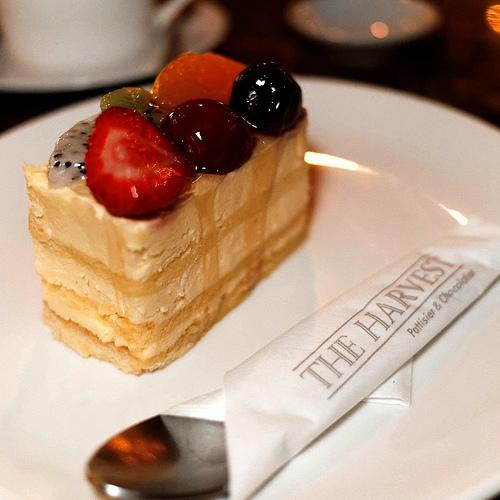Explain how the fruits on top of the cake have been prepared or presented. The fruits have been sliced, and some are juicy or have liquid dripping from them. Can you estimate how many layers are in the dessert? There seem to be multiple layers, though it's difficult to give an exact number from the given details. What can be found in the background of the image? A coffee mug can be seen in the background. Describe the napkin's appearance and any notable details about it. The napkin is white, has the restaurant logo and words printed on it, and is wrapped around the spoon. Analyze the emotions or sentiments that the image might evoke in viewers. The image may evoke feelings of indulgence, luxury, and deliciousness. Can you list some of the fruits on top of the dessert? Strawberries, kiwi slices, a cut cherry, a blueberry, a piece of mandarin orange, and black raspberry. What is unique about the white plate in the image, and what does it hold? The white plate features a light shining off of it and has the cake and spoon on it. What is the main dessert item presented in the image? A layered ice cream dessert topped with mixed fruits and fruit juices running down its side. Please describe the spoon found in the image. The silver spoon has a silver bowl and a tip, with a reflection on it. It is wrapped in a white napkin. What is the name of the restaurant mentioned in the image, and where is it located? The Harvest is the name of the restaurant, and it is mentioned on the napkin. Could you find the honeycomb decoration placed beside the dessert? It adds a unique touch to the presentation. There is no mention of a honeycomb or any additional decoration besides the main objects described in the image, so this object is non-existent. Notice the blue tablecloth underneath the plate, with a floral pattern around the edges. No, it's not mentioned in the image. Look for a glass of red wine on the table, near the dessert plate. It's half-full with a long stem. There is no information about a wine glass or any kind of drink in the scene, so this object is non-existent. Can you find the name of the chef who made this dessert? It's written on the napkin in cursive letters. The only writing mentioned on the napkin is the restaurant logo, so the object mentioned (the chef's name) is non-existent in the image. Don't miss the chocolate sauce drizzled on the plate next to the cake, forming a beautiful swirl design. There are no instructions on chocolate sauce or any drizzle on the plate, so this object is non-existent. 